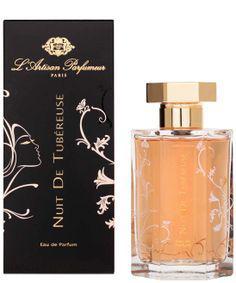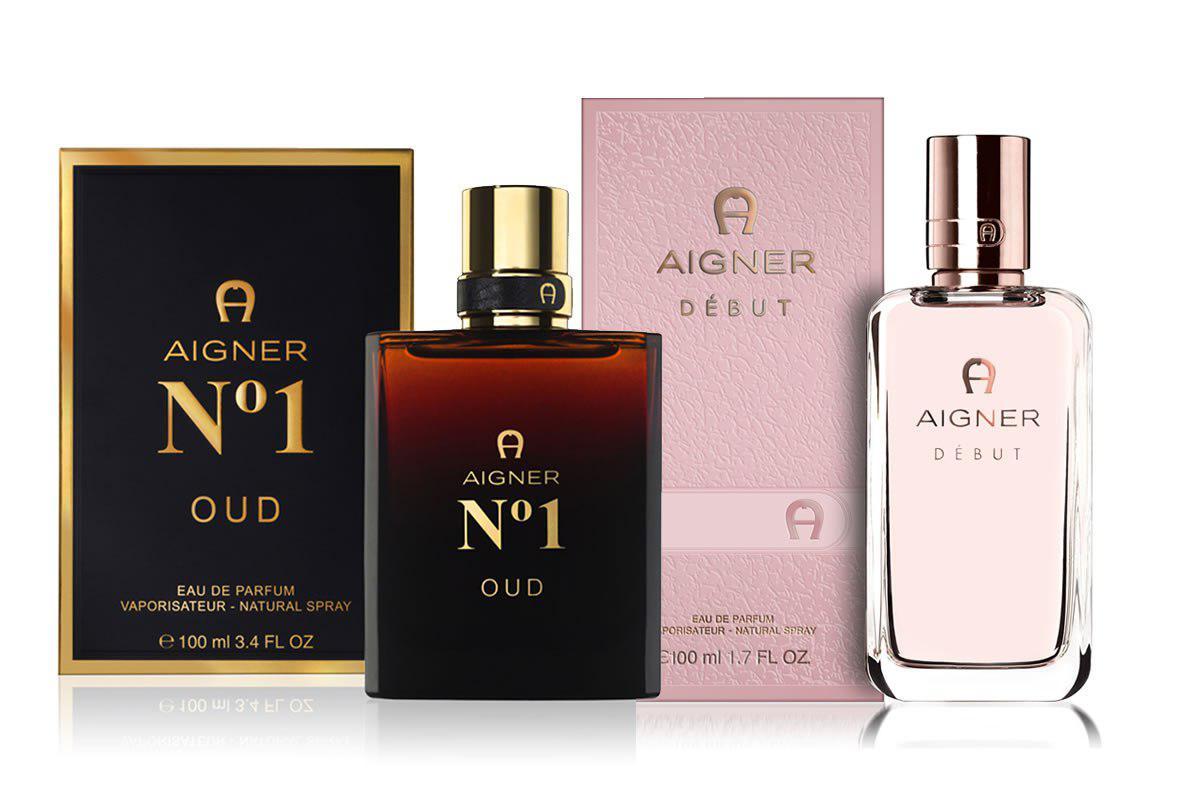The first image is the image on the left, the second image is the image on the right. Assess this claim about the two images: "There are more containers in the image on the right.". Correct or not? Answer yes or no. Yes. The first image is the image on the left, the second image is the image on the right. Evaluate the accuracy of this statement regarding the images: "One image shows a silver cylinder shape next to a silver upright box.". Is it true? Answer yes or no. No. 